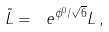<formula> <loc_0><loc_0><loc_500><loc_500>\tilde { L } = \ e ^ { \phi ^ { 0 } / \sqrt { 6 } } L \, ,</formula> 